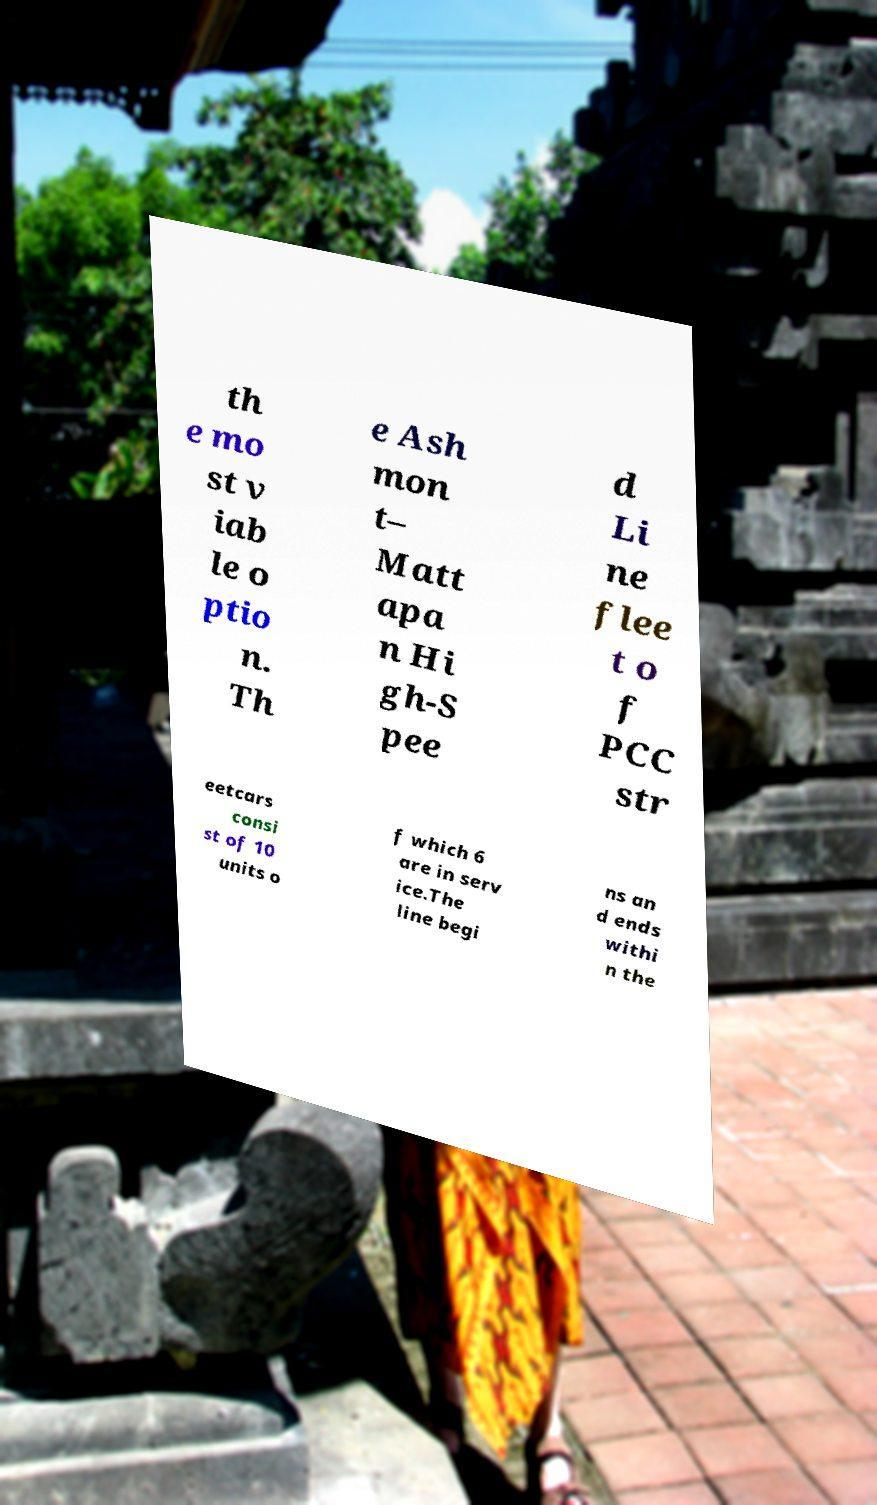Can you read and provide the text displayed in the image?This photo seems to have some interesting text. Can you extract and type it out for me? th e mo st v iab le o ptio n. Th e Ash mon t– Matt apa n Hi gh-S pee d Li ne flee t o f PCC str eetcars consi st of 10 units o f which 6 are in serv ice.The line begi ns an d ends withi n the 